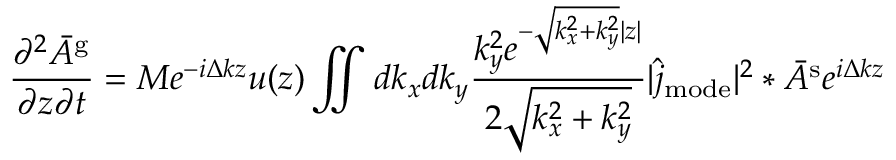Convert formula to latex. <formula><loc_0><loc_0><loc_500><loc_500>\frac { \partial ^ { 2 } \bar { A } ^ { g } } { \partial z \partial t } = M e ^ { - i \Delta k z } u ( z ) \iint d k _ { x } d k _ { y } \frac { k _ { y } ^ { 2 } e ^ { - \sqrt { k _ { x } ^ { 2 } + k _ { y } ^ { 2 } } | z | } } { 2 \sqrt { k _ { x } ^ { 2 } + k _ { y } ^ { 2 } } } | \hat { j } _ { m o d e } | ^ { 2 } \ast \bar { A } ^ { s } e ^ { i \Delta k z }</formula> 